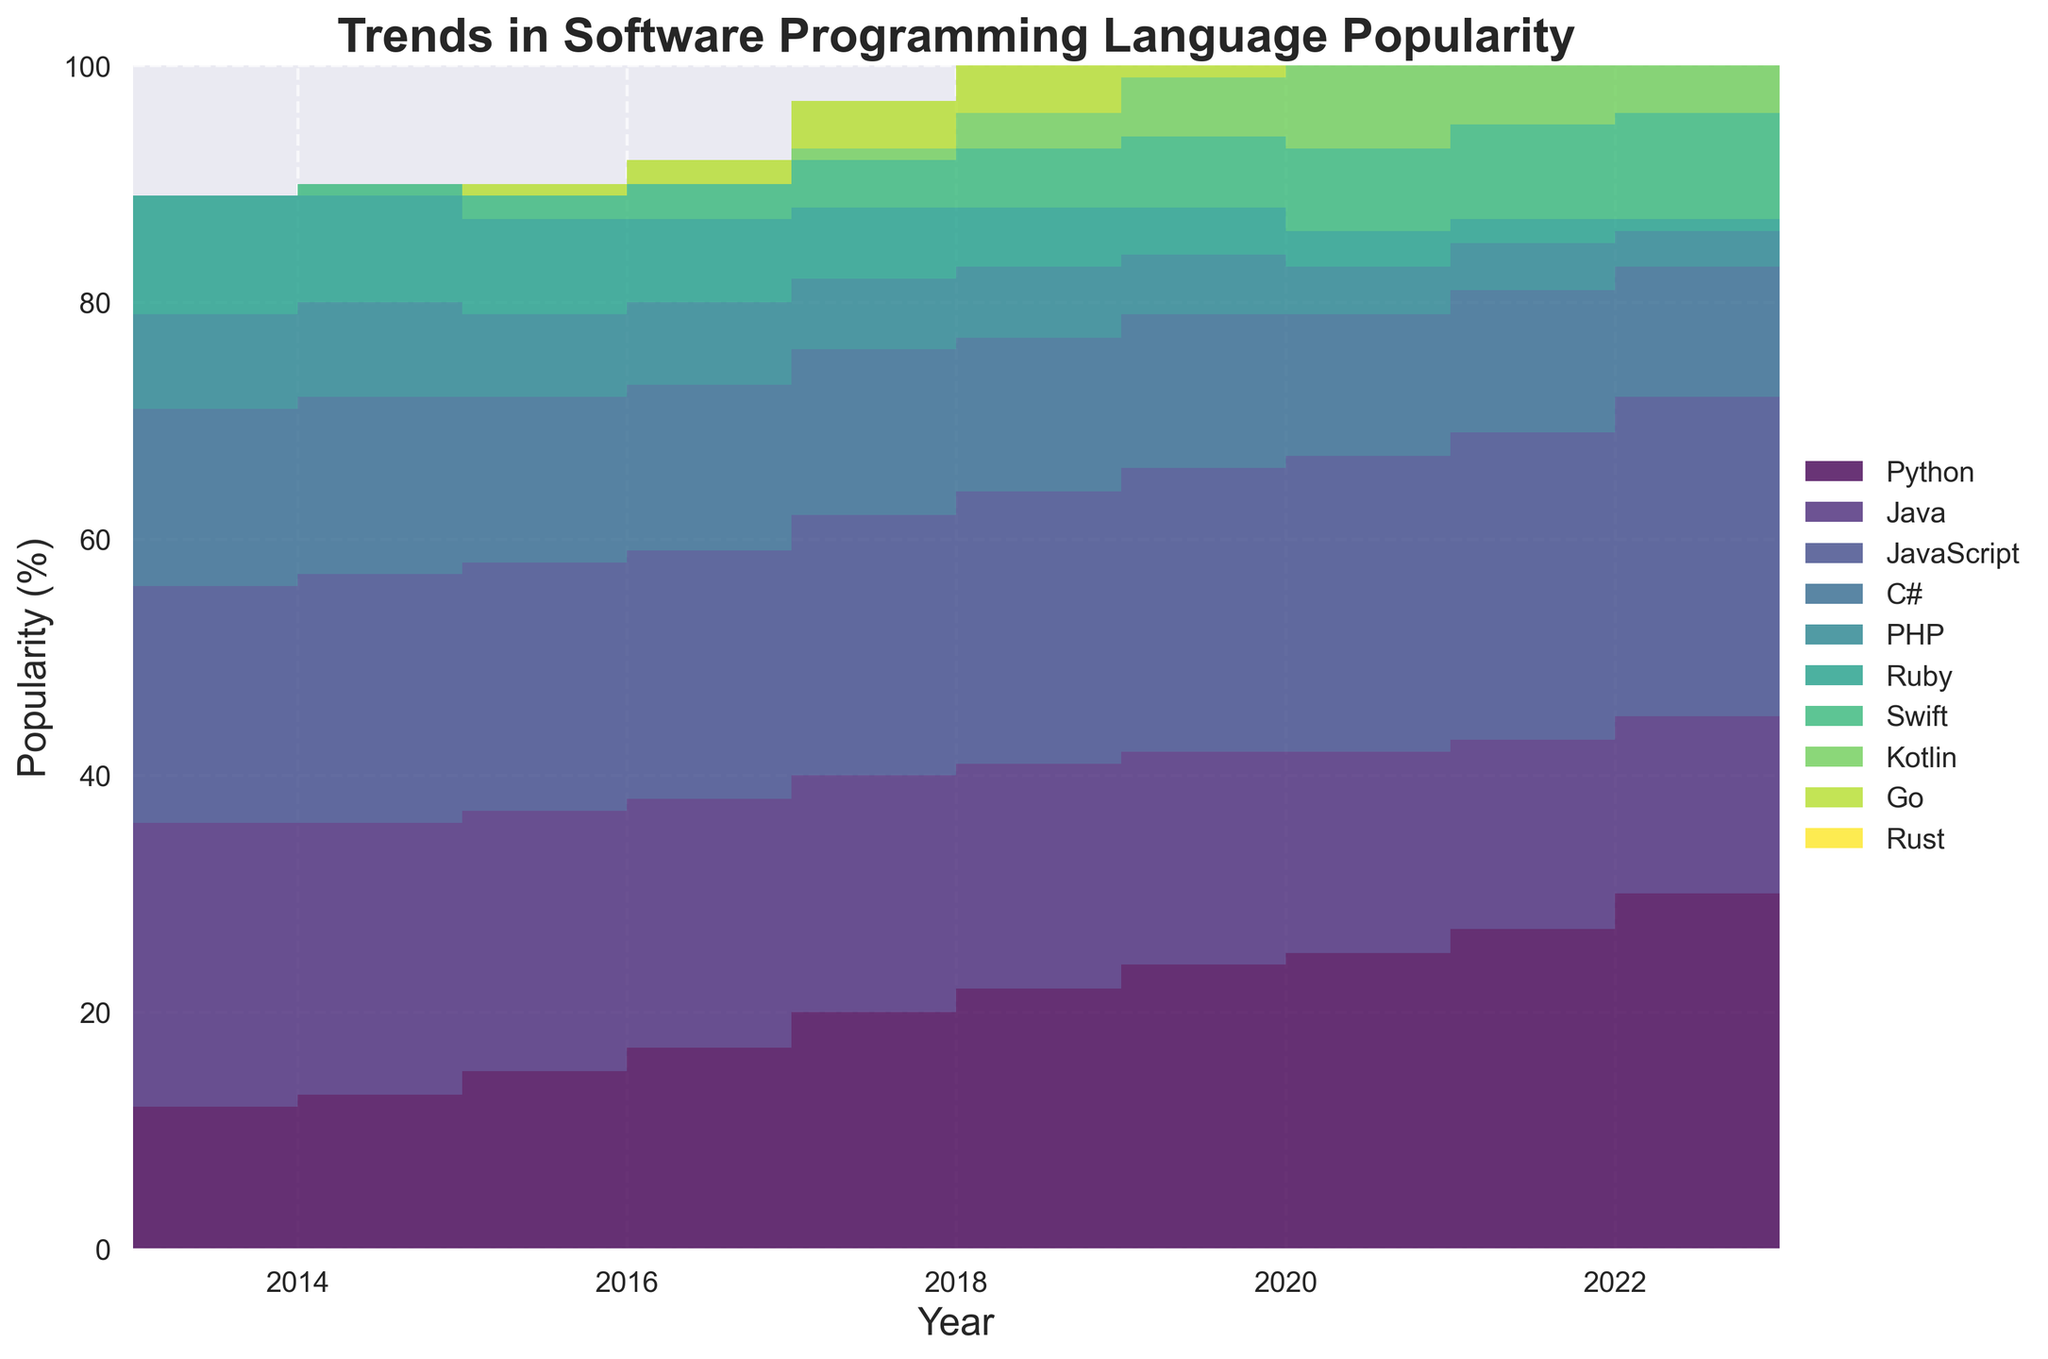Which year appears to be in the middle of the timeframe displayed on the graph? The timeframe spans from 2013 to 2023, so the middle year is approximately the middle of this range. (2013 + 2023) / 2 = 2018
Answer: 2018 Between 2013 and 2023, which programming language has seen the most significant increase in popularity? To identify this, look at the starting percentage in 2013 and compare it to the percentage in 2023 for each language. Python goes from 11% to 30%, the highest increase.
Answer: Python Which language had the highest popularity at the beginning of the timeframe? By examining the plot at the 2013 mark, Java had the highest popularity with 24%.
Answer: Java Which two languages show the most similar trend from 2013 to 2023? Look for lines with similar shapes or trends; JavaScript and Python show a somewhat parallel increase from 2013 to 2023.
Answer: JavaScript and Python Has C# increased or decreased in popularity over the decade? Observe the C# line from 2013 to 2023. C# shows a slight decrease from 16% in 2013 to 11% in 2023.
Answer: Decreased Which language was introduced first: Kotlin or Swift? Look at the lines for both languages; Swift appears in 2015 and Kotlin in 2018.
Answer: Swift At any point, does PHP surpass Python in popularity? Check the plot areas; PHP starts higher than Python but falls below it from 2014 onward, never surpassing it again.
Answer: No Between 2015 and 2020, which language's popularity remained the most steady? JavaScript shows the least variation, staying between 21% and 24%.
Answer: JavaScript In which year did Swift first appear in the plot? Examine the Swift line, which starts appearing in 2015.
Answer: 2015 Which language had no popularity in 2013 but has gained some by 2023? Look at only the languages that start at 0 in 2013; Swift, Kotlin, Go, and Rust all start gaining popularity during the timeframe.
Answer: Swift, Kotlin, Go, Rust 